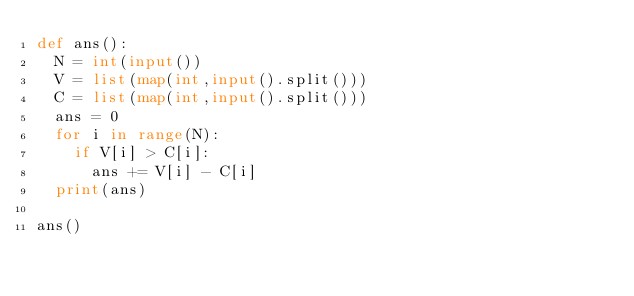<code> <loc_0><loc_0><loc_500><loc_500><_Python_>def ans():
  N = int(input())
  V = list(map(int,input().split()))
  C = list(map(int,input().split()))
  ans = 0
  for i in range(N):
    if V[i] > C[i]:
      ans += V[i] - C[i]
  print(ans)

ans()</code> 